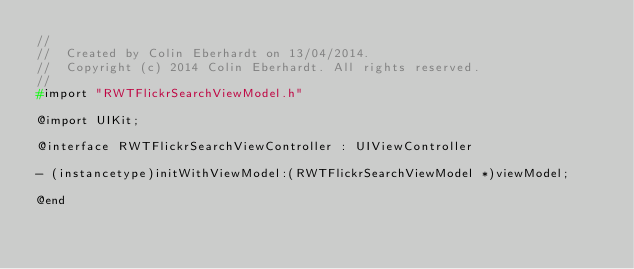<code> <loc_0><loc_0><loc_500><loc_500><_C_>//
//  Created by Colin Eberhardt on 13/04/2014.
//  Copyright (c) 2014 Colin Eberhardt. All rights reserved.
//
#import "RWTFlickrSearchViewModel.h"

@import UIKit;

@interface RWTFlickrSearchViewController : UIViewController

- (instancetype)initWithViewModel:(RWTFlickrSearchViewModel *)viewModel;

@end
</code> 